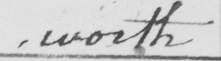What text is written in this handwritten line? worth 